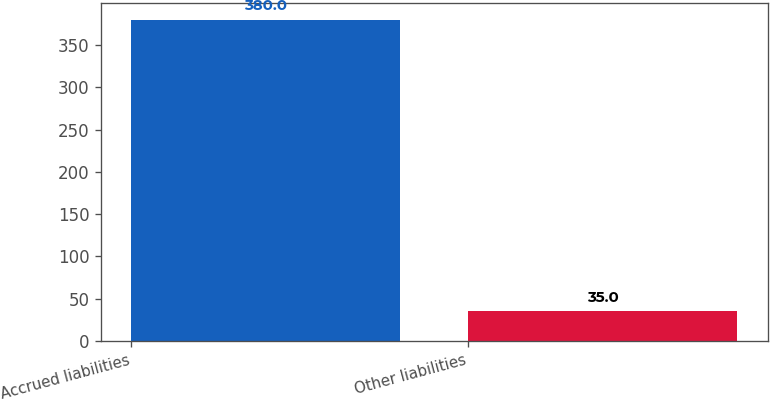Convert chart. <chart><loc_0><loc_0><loc_500><loc_500><bar_chart><fcel>Accrued liabilities<fcel>Other liabilities<nl><fcel>380<fcel>35<nl></chart> 